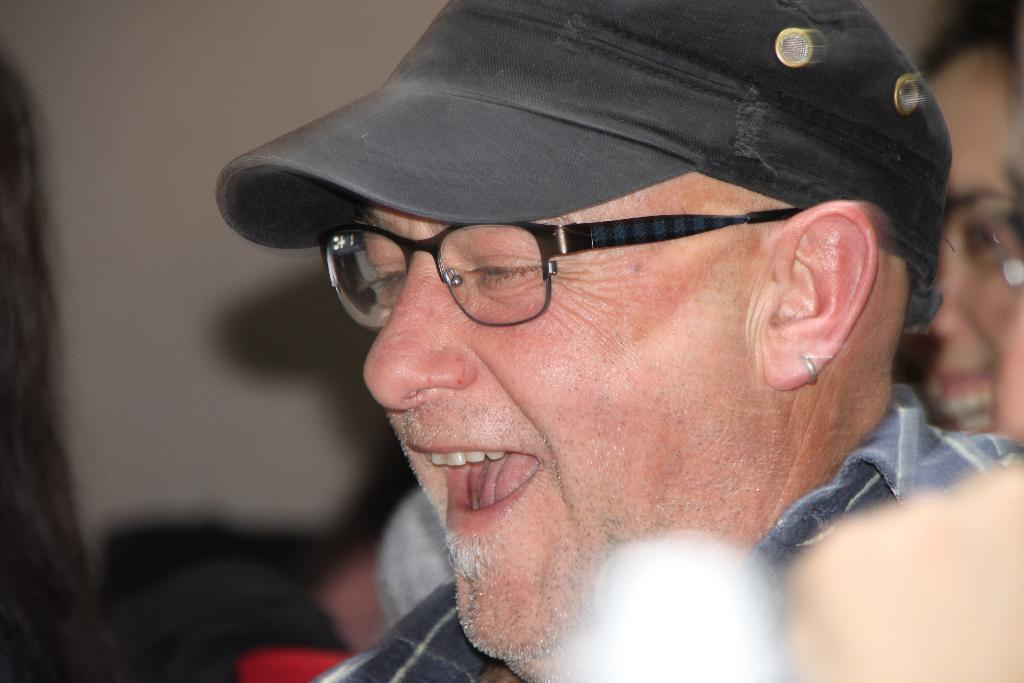What is the main subject of the image? There is a person in the image. What is the person wearing on their head? The person is wearing a black hat. What type of eyewear is the person wearing? The person is wearing black glasses. What color is the shirt the person is wearing? The person is wearing a black shirt. Can you describe the background of the image? There are other persons in the background of the image, and there is a wall in the background as well. How long does it take for the paste to dry in the image? There is no mention of paste in the image, so it is not possible to determine how long it would take for the paste to dry. 